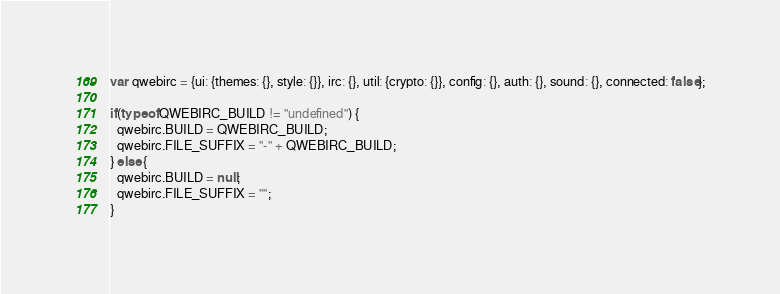<code> <loc_0><loc_0><loc_500><loc_500><_JavaScript_>var qwebirc = {ui: {themes: {}, style: {}}, irc: {}, util: {crypto: {}}, config: {}, auth: {}, sound: {}, connected: false};

if(typeof QWEBIRC_BUILD != "undefined") {
  qwebirc.BUILD = QWEBIRC_BUILD;
  qwebirc.FILE_SUFFIX = "-" + QWEBIRC_BUILD;
} else {
  qwebirc.BUILD = null;
  qwebirc.FILE_SUFFIX = "";
}
</code> 